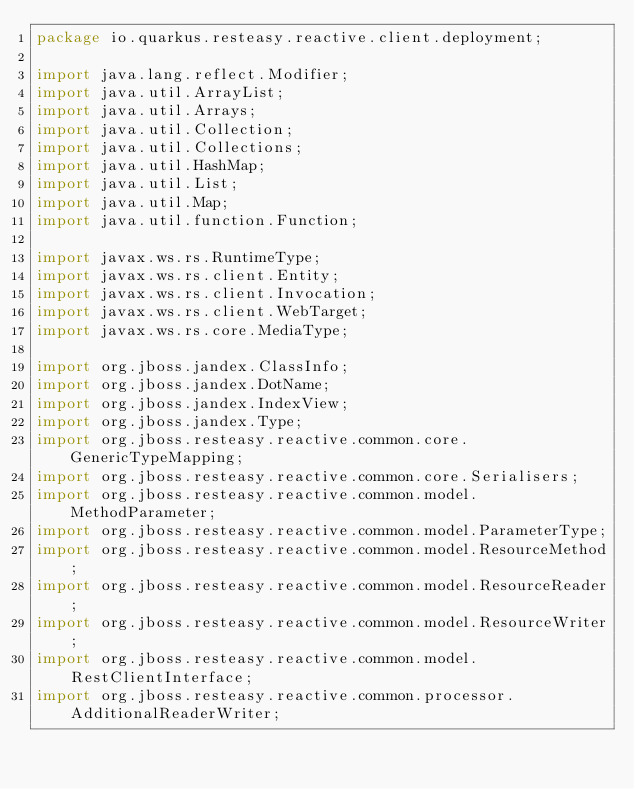<code> <loc_0><loc_0><loc_500><loc_500><_Java_>package io.quarkus.resteasy.reactive.client.deployment;

import java.lang.reflect.Modifier;
import java.util.ArrayList;
import java.util.Arrays;
import java.util.Collection;
import java.util.Collections;
import java.util.HashMap;
import java.util.List;
import java.util.Map;
import java.util.function.Function;

import javax.ws.rs.RuntimeType;
import javax.ws.rs.client.Entity;
import javax.ws.rs.client.Invocation;
import javax.ws.rs.client.WebTarget;
import javax.ws.rs.core.MediaType;

import org.jboss.jandex.ClassInfo;
import org.jboss.jandex.DotName;
import org.jboss.jandex.IndexView;
import org.jboss.jandex.Type;
import org.jboss.resteasy.reactive.common.core.GenericTypeMapping;
import org.jboss.resteasy.reactive.common.core.Serialisers;
import org.jboss.resteasy.reactive.common.model.MethodParameter;
import org.jboss.resteasy.reactive.common.model.ParameterType;
import org.jboss.resteasy.reactive.common.model.ResourceMethod;
import org.jboss.resteasy.reactive.common.model.ResourceReader;
import org.jboss.resteasy.reactive.common.model.ResourceWriter;
import org.jboss.resteasy.reactive.common.model.RestClientInterface;
import org.jboss.resteasy.reactive.common.processor.AdditionalReaderWriter;</code> 